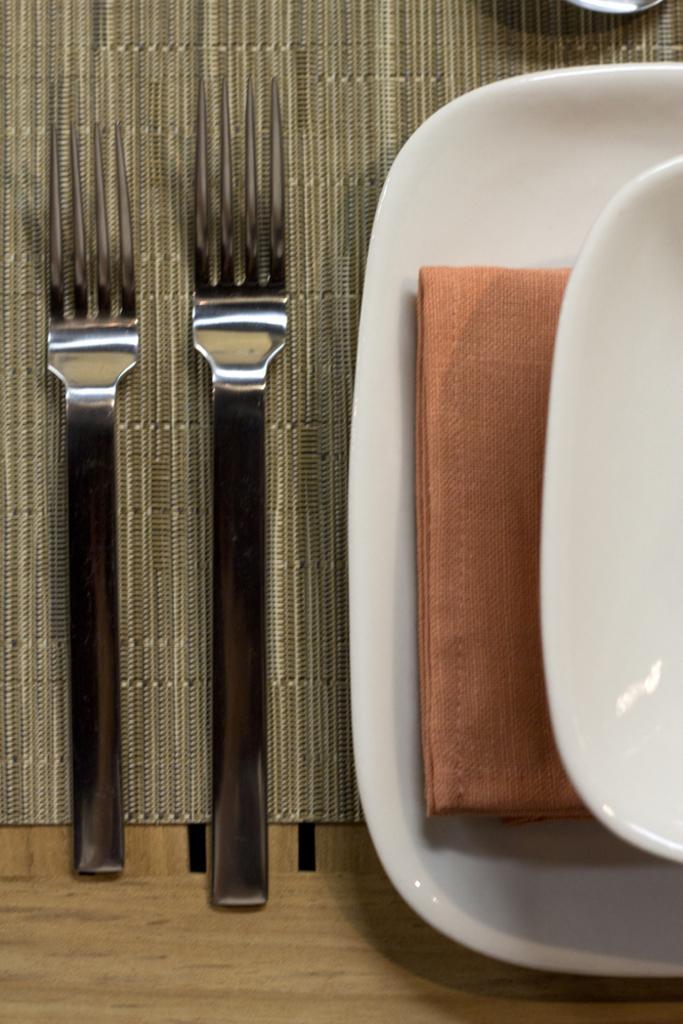Describe this image in one or two sentences. In this image we can see forks and plates placed on the table. 